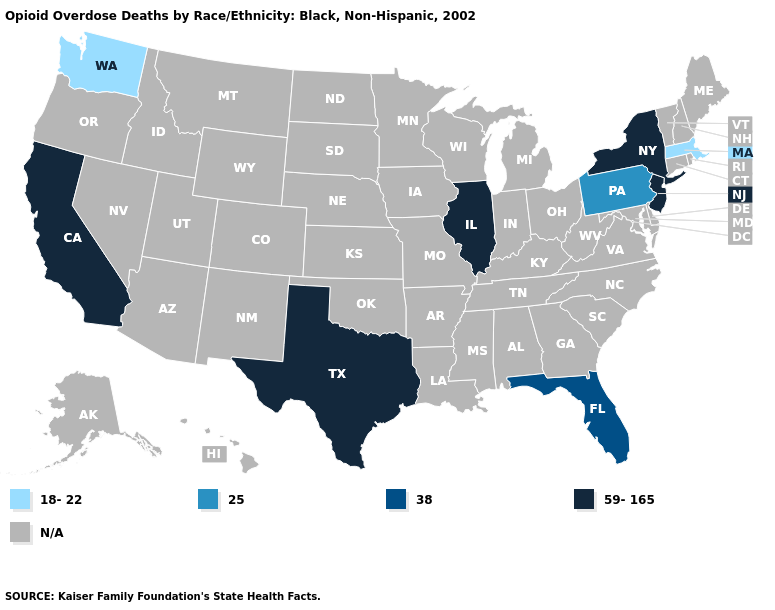What is the highest value in states that border Rhode Island?
Short answer required. 18-22. What is the value of Delaware?
Keep it brief. N/A. What is the value of Texas?
Short answer required. 59-165. What is the value of Arizona?
Quick response, please. N/A. Which states have the lowest value in the USA?
Keep it brief. Massachusetts, Washington. Name the states that have a value in the range 25?
Concise answer only. Pennsylvania. What is the value of Mississippi?
Answer briefly. N/A. Name the states that have a value in the range 38?
Short answer required. Florida. 